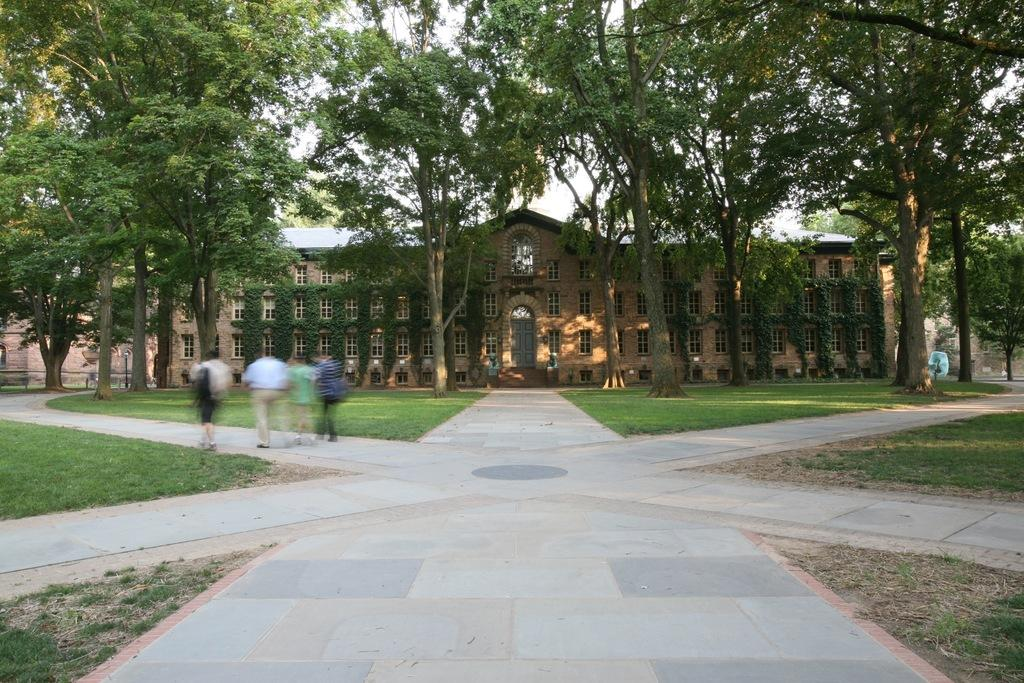What is the surface that the people are standing on in the image? There are people on the ground in the image. What type of vegetation can be seen in the image? There is grass visible in the image. What other natural elements are present in the image? There are trees in the image. What type of structure can be seen in the image? There is a building in the image. What else can be seen in the image besides the people, grass, trees, and building? There are some objects in the image. What is visible in the background of the image? The sky is visible in the background of the image. What is the name of the brother of the person standing next to the tree in the image? There is no information about a brother or a specific person standing next to a tree in the image. 